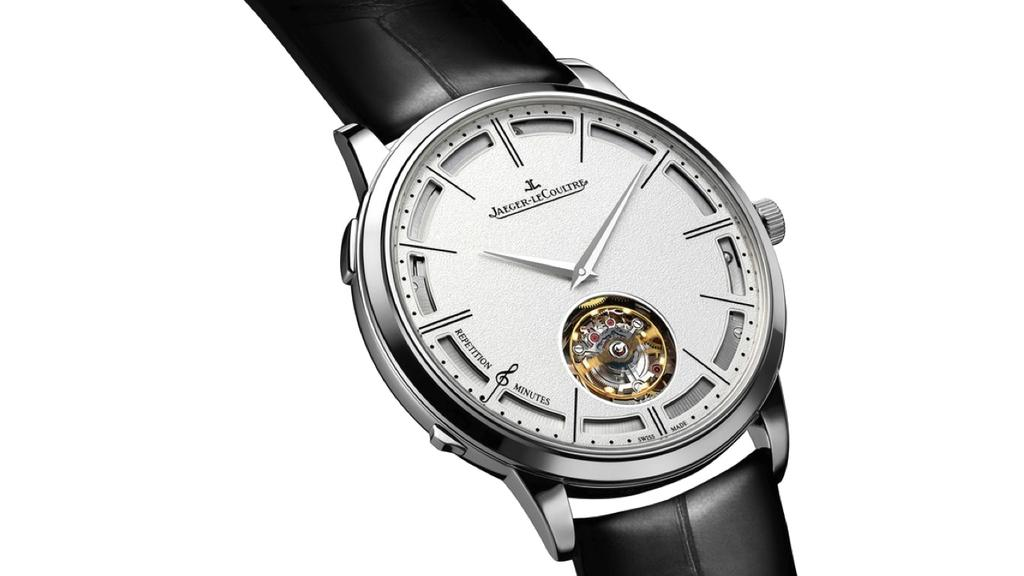<image>
Present a compact description of the photo's key features. A watch that says Jaeger LeCoultre on the face of it. 